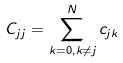<formula> <loc_0><loc_0><loc_500><loc_500>C _ { j j } = \sum _ { k = 0 , k \neq j } ^ { N } c _ { j k }</formula> 